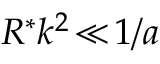<formula> <loc_0><loc_0><loc_500><loc_500>R ^ { * } k ^ { 2 } \, \ll \, 1 / a</formula> 